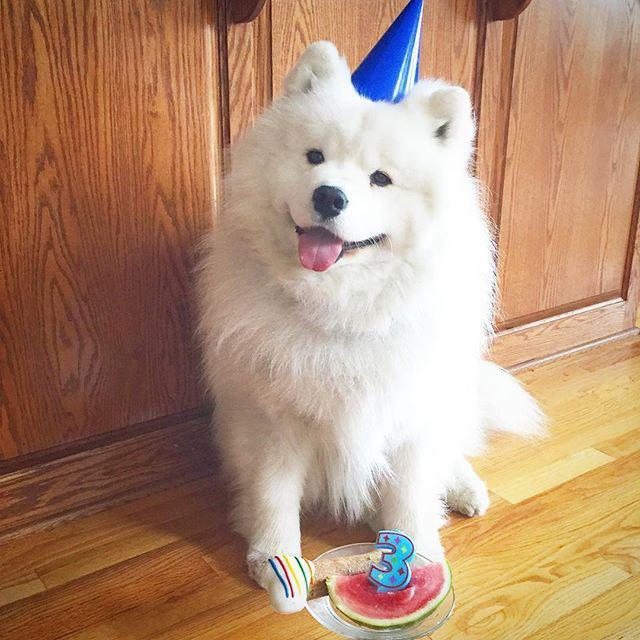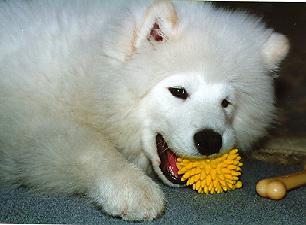The first image is the image on the left, the second image is the image on the right. Assess this claim about the two images: "One image shows a reclining white dog chewing on something.". Correct or not? Answer yes or no. Yes. The first image is the image on the left, the second image is the image on the right. For the images displayed, is the sentence "One of the images show a single dog standing on all four legs." factually correct? Answer yes or no. No. 